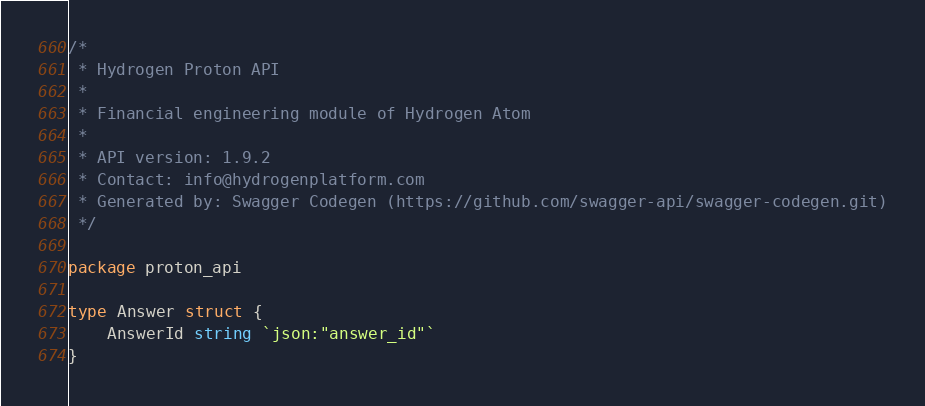Convert code to text. <code><loc_0><loc_0><loc_500><loc_500><_Go_>/*
 * Hydrogen Proton API
 *
 * Financial engineering module of Hydrogen Atom
 *
 * API version: 1.9.2
 * Contact: info@hydrogenplatform.com
 * Generated by: Swagger Codegen (https://github.com/swagger-api/swagger-codegen.git)
 */

package proton_api

type Answer struct {
	AnswerId string `json:"answer_id"`
}
</code> 